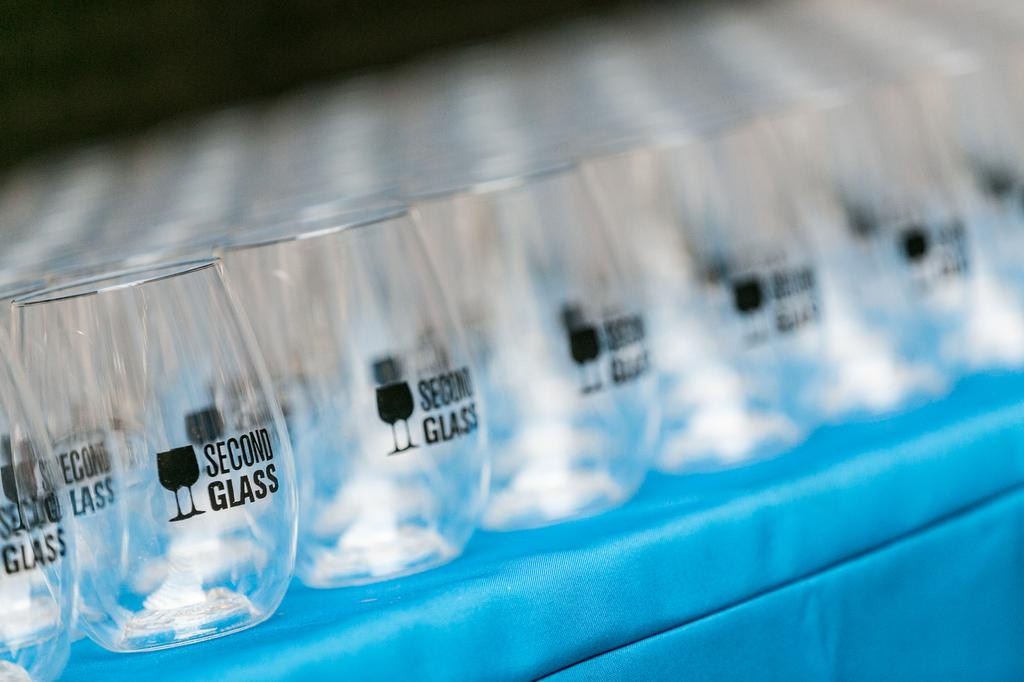<image>
Provide a brief description of the given image. Numerous short glasses that say Second Glass are placed together on a table. 